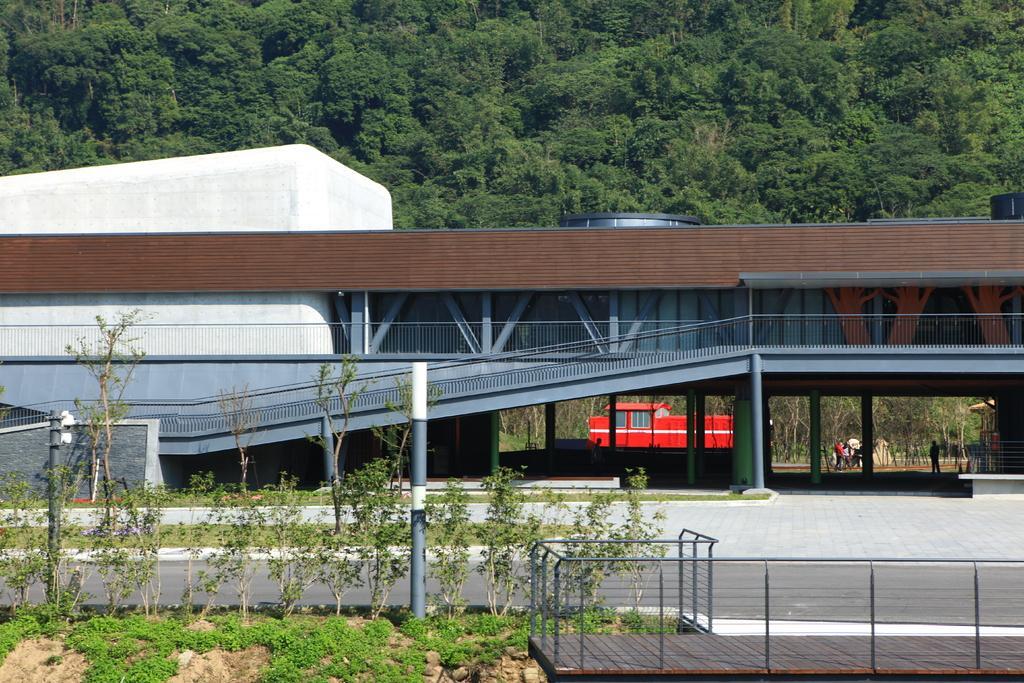In one or two sentences, can you explain what this image depicts? In this image, we can see some architecture with pillars and poles. Railings, wall we can see here. At the bottom, there are few plants, grillz, road, footpath. Here we can see some red color. Background there are few people we can see. Top of the image, there are so many trees we can see. 